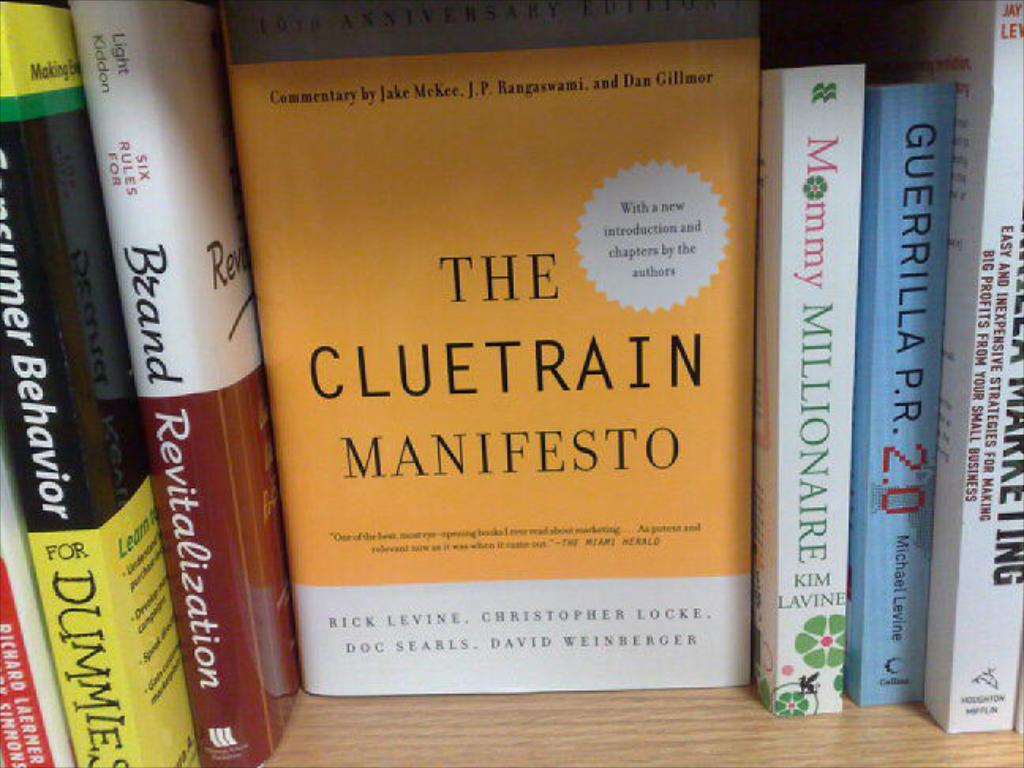Provide a one-sentence caption for the provided image. The Cluetrain Manifesto is on the book shelf next to Mommy Millionaire. 